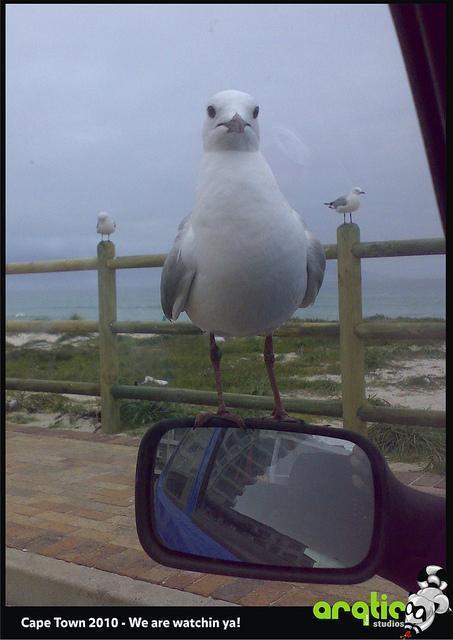How many of the people are wearing shoes with yellow on them ?
Give a very brief answer. 0. 